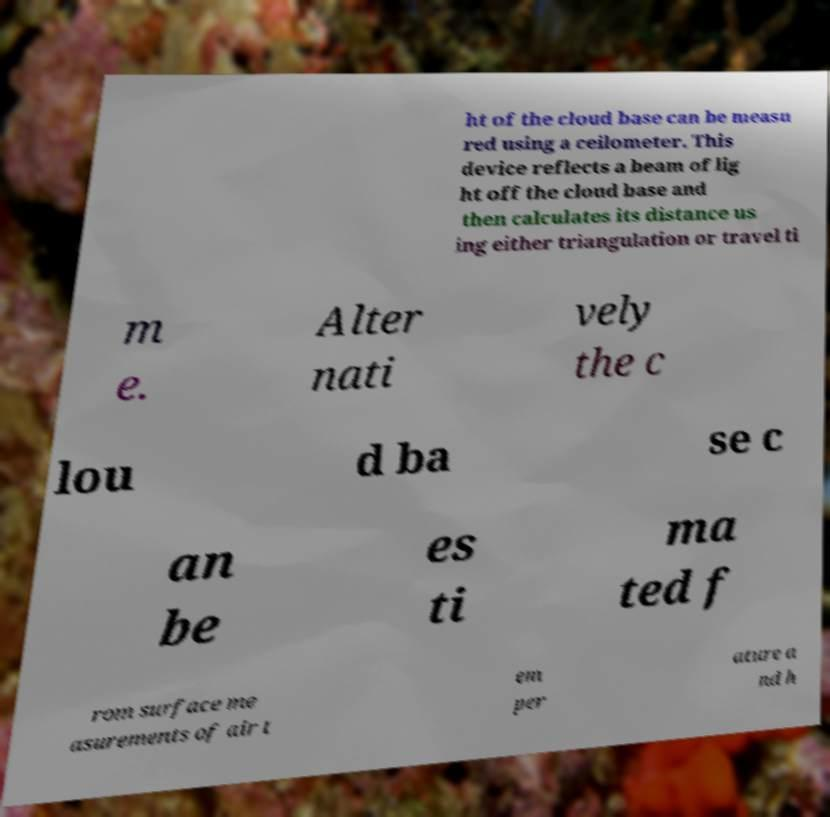I need the written content from this picture converted into text. Can you do that? ht of the cloud base can be measu red using a ceilometer. This device reflects a beam of lig ht off the cloud base and then calculates its distance us ing either triangulation or travel ti m e. Alter nati vely the c lou d ba se c an be es ti ma ted f rom surface me asurements of air t em per ature a nd h 